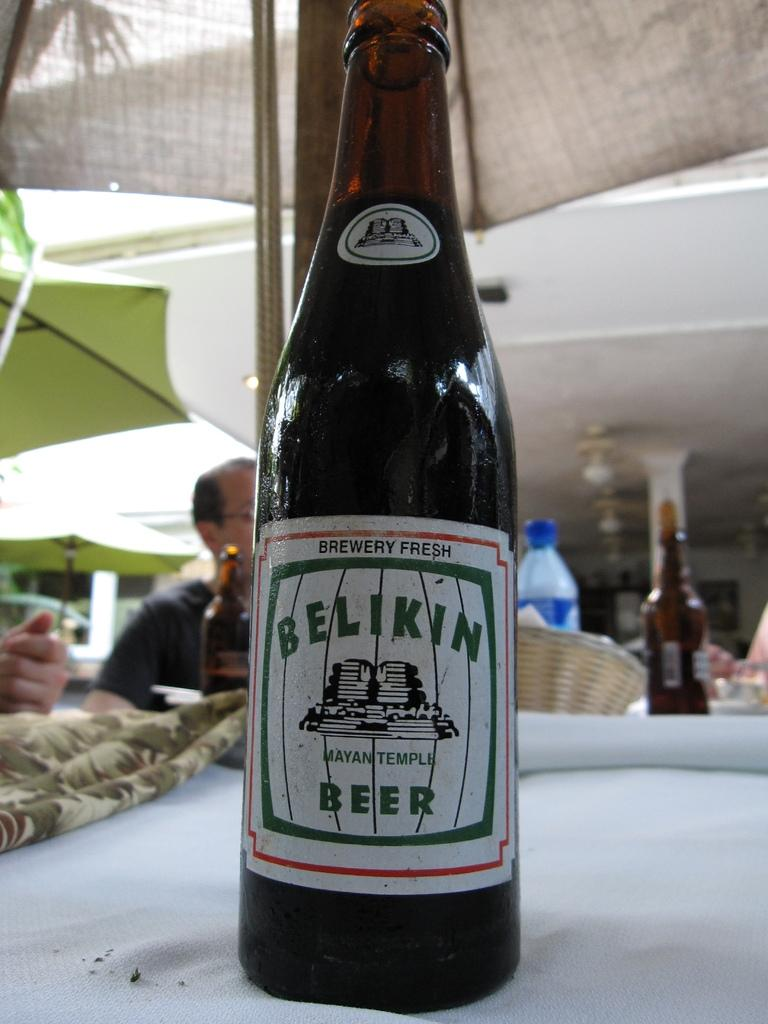<image>
Give a short and clear explanation of the subsequent image. a bottle of brewery fresh belikin beer on a cloth table 